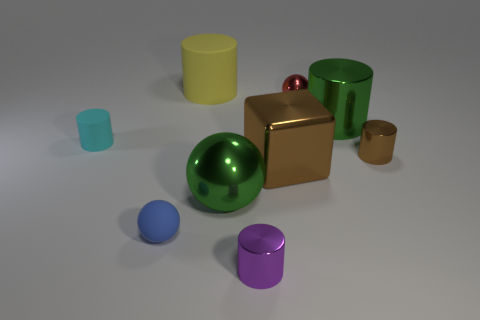Subtract all yellow cylinders. How many cylinders are left? 4 Subtract all small cyan cylinders. How many cylinders are left? 4 Subtract all red cylinders. Subtract all purple balls. How many cylinders are left? 5 Add 1 cyan cylinders. How many objects exist? 10 Subtract all blocks. How many objects are left? 8 Subtract all tiny red shiny balls. Subtract all big things. How many objects are left? 4 Add 2 big yellow cylinders. How many big yellow cylinders are left? 3 Add 3 shiny balls. How many shiny balls exist? 5 Subtract 0 blue cylinders. How many objects are left? 9 